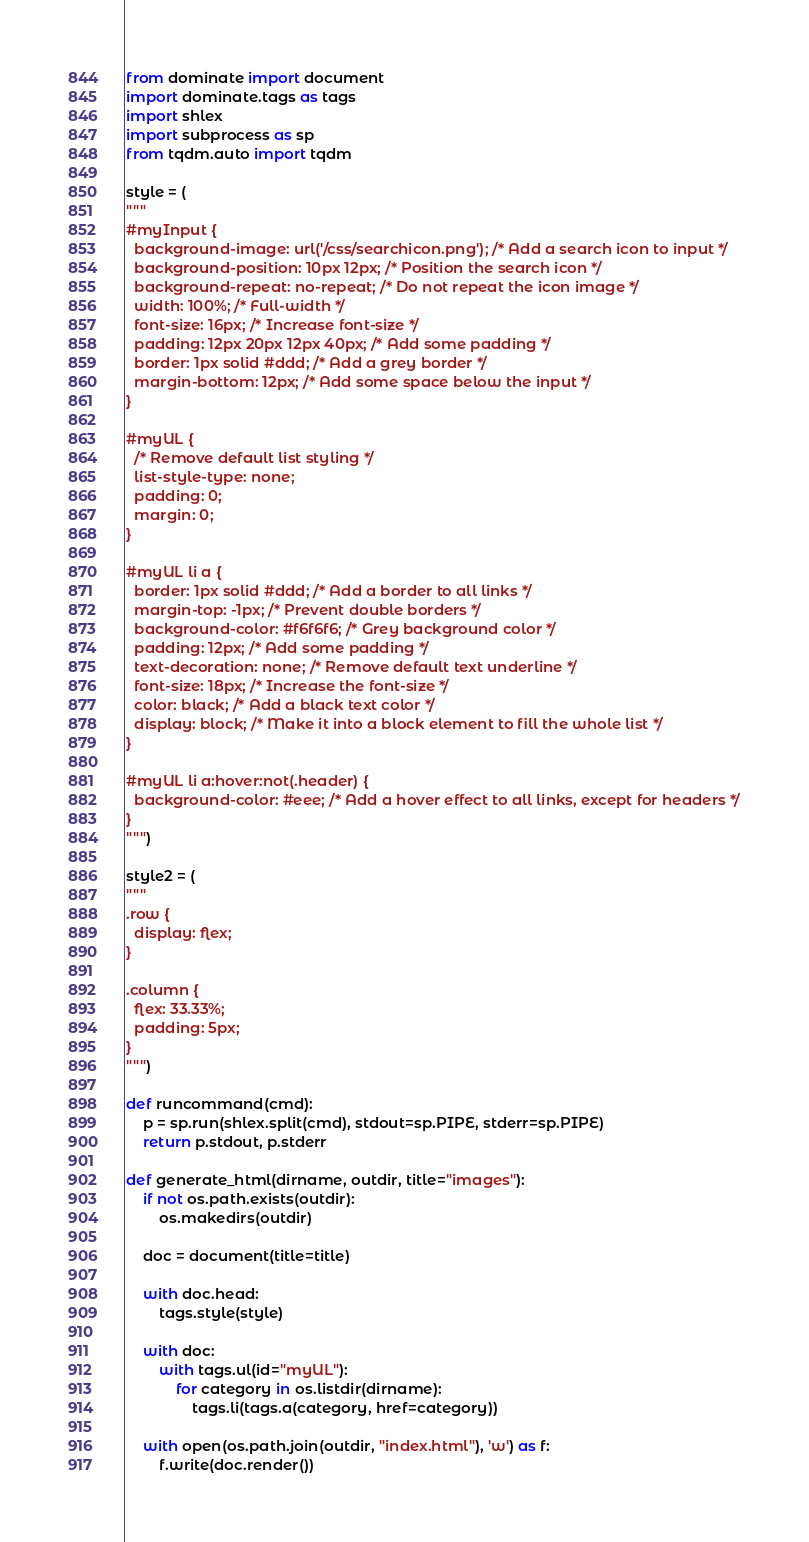<code> <loc_0><loc_0><loc_500><loc_500><_Python_>from dominate import document
import dominate.tags as tags
import shlex
import subprocess as sp
from tqdm.auto import tqdm

style = (
"""
#myInput {
  background-image: url('/css/searchicon.png'); /* Add a search icon to input */
  background-position: 10px 12px; /* Position the search icon */
  background-repeat: no-repeat; /* Do not repeat the icon image */
  width: 100%; /* Full-width */
  font-size: 16px; /* Increase font-size */
  padding: 12px 20px 12px 40px; /* Add some padding */
  border: 1px solid #ddd; /* Add a grey border */
  margin-bottom: 12px; /* Add some space below the input */
}

#myUL {
  /* Remove default list styling */
  list-style-type: none;
  padding: 0;
  margin: 0;
}

#myUL li a {
  border: 1px solid #ddd; /* Add a border to all links */
  margin-top: -1px; /* Prevent double borders */
  background-color: #f6f6f6; /* Grey background color */
  padding: 12px; /* Add some padding */
  text-decoration: none; /* Remove default text underline */
  font-size: 18px; /* Increase the font-size */
  color: black; /* Add a black text color */
  display: block; /* Make it into a block element to fill the whole list */
}

#myUL li a:hover:not(.header) {
  background-color: #eee; /* Add a hover effect to all links, except for headers */
}
""")

style2 = (
"""
.row {
  display: flex;
}

.column {
  flex: 33.33%;
  padding: 5px;
}
""")

def runcommand(cmd):
    p = sp.run(shlex.split(cmd), stdout=sp.PIPE, stderr=sp.PIPE)
    return p.stdout, p.stderr

def generate_html(dirname, outdir, title="images"):
    if not os.path.exists(outdir):
        os.makedirs(outdir)

    doc = document(title=title)

    with doc.head:
        tags.style(style)

    with doc:
        with tags.ul(id="myUL"):
            for category in os.listdir(dirname):
                tags.li(tags.a(category, href=category))

    with open(os.path.join(outdir, "index.html"), 'w') as f:
        f.write(doc.render())
</code> 